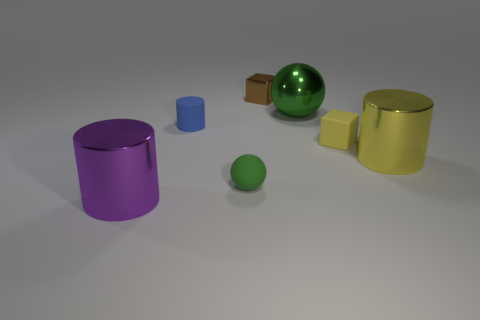Subtract all matte cylinders. How many cylinders are left? 2 Subtract all yellow cylinders. How many cylinders are left? 2 Add 1 purple shiny cylinders. How many objects exist? 8 Subtract all blocks. How many objects are left? 5 Subtract 1 cylinders. How many cylinders are left? 2 Subtract all cylinders. Subtract all small cylinders. How many objects are left? 3 Add 6 small matte balls. How many small matte balls are left? 7 Add 1 yellow rubber blocks. How many yellow rubber blocks exist? 2 Subtract 1 blue cylinders. How many objects are left? 6 Subtract all purple spheres. Subtract all brown blocks. How many spheres are left? 2 